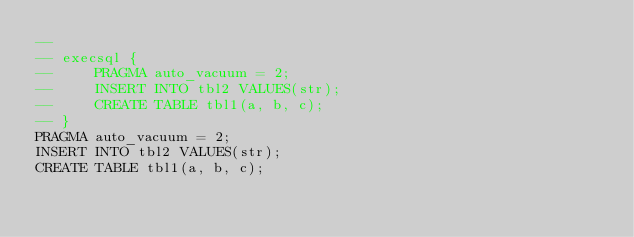Convert code to text. <code><loc_0><loc_0><loc_500><loc_500><_SQL_>-- 
-- execsql {
--     PRAGMA auto_vacuum = 2;
--     INSERT INTO tbl2 VALUES(str);
--     CREATE TABLE tbl1(a, b, c);
-- }
PRAGMA auto_vacuum = 2;
INSERT INTO tbl2 VALUES(str);
CREATE TABLE tbl1(a, b, c);
</code> 